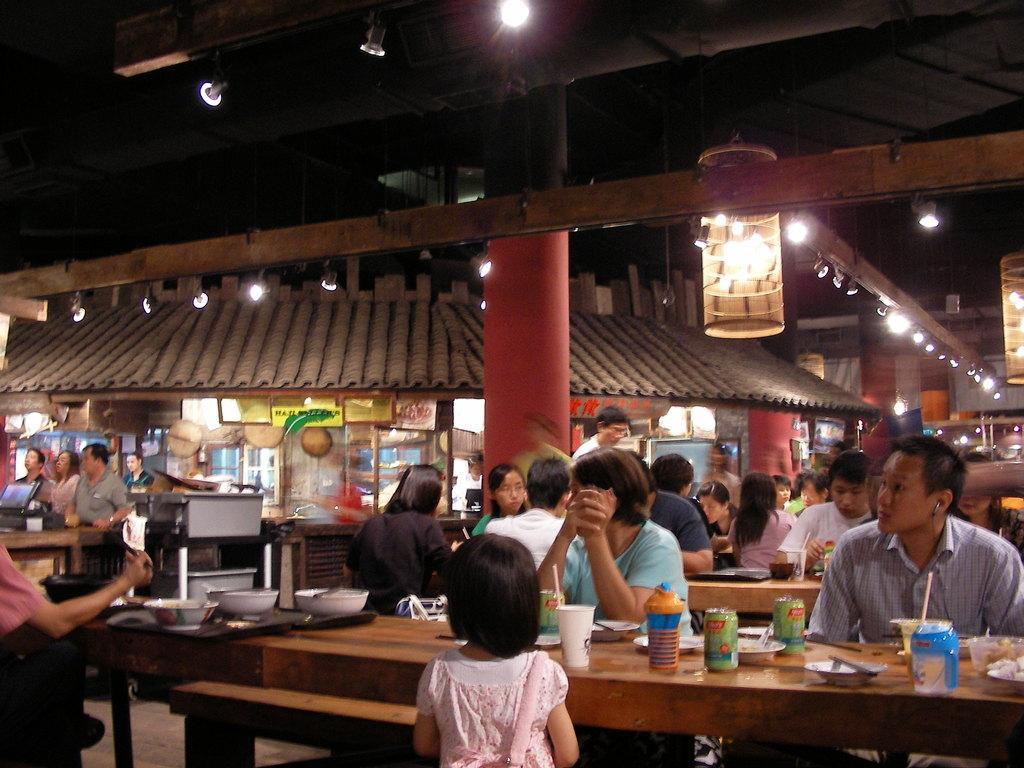Please provide a concise description of this image. As we can see in the image there is a roof, light, few people sitting on chairs and there is a table. On table there are bottles and glass. 